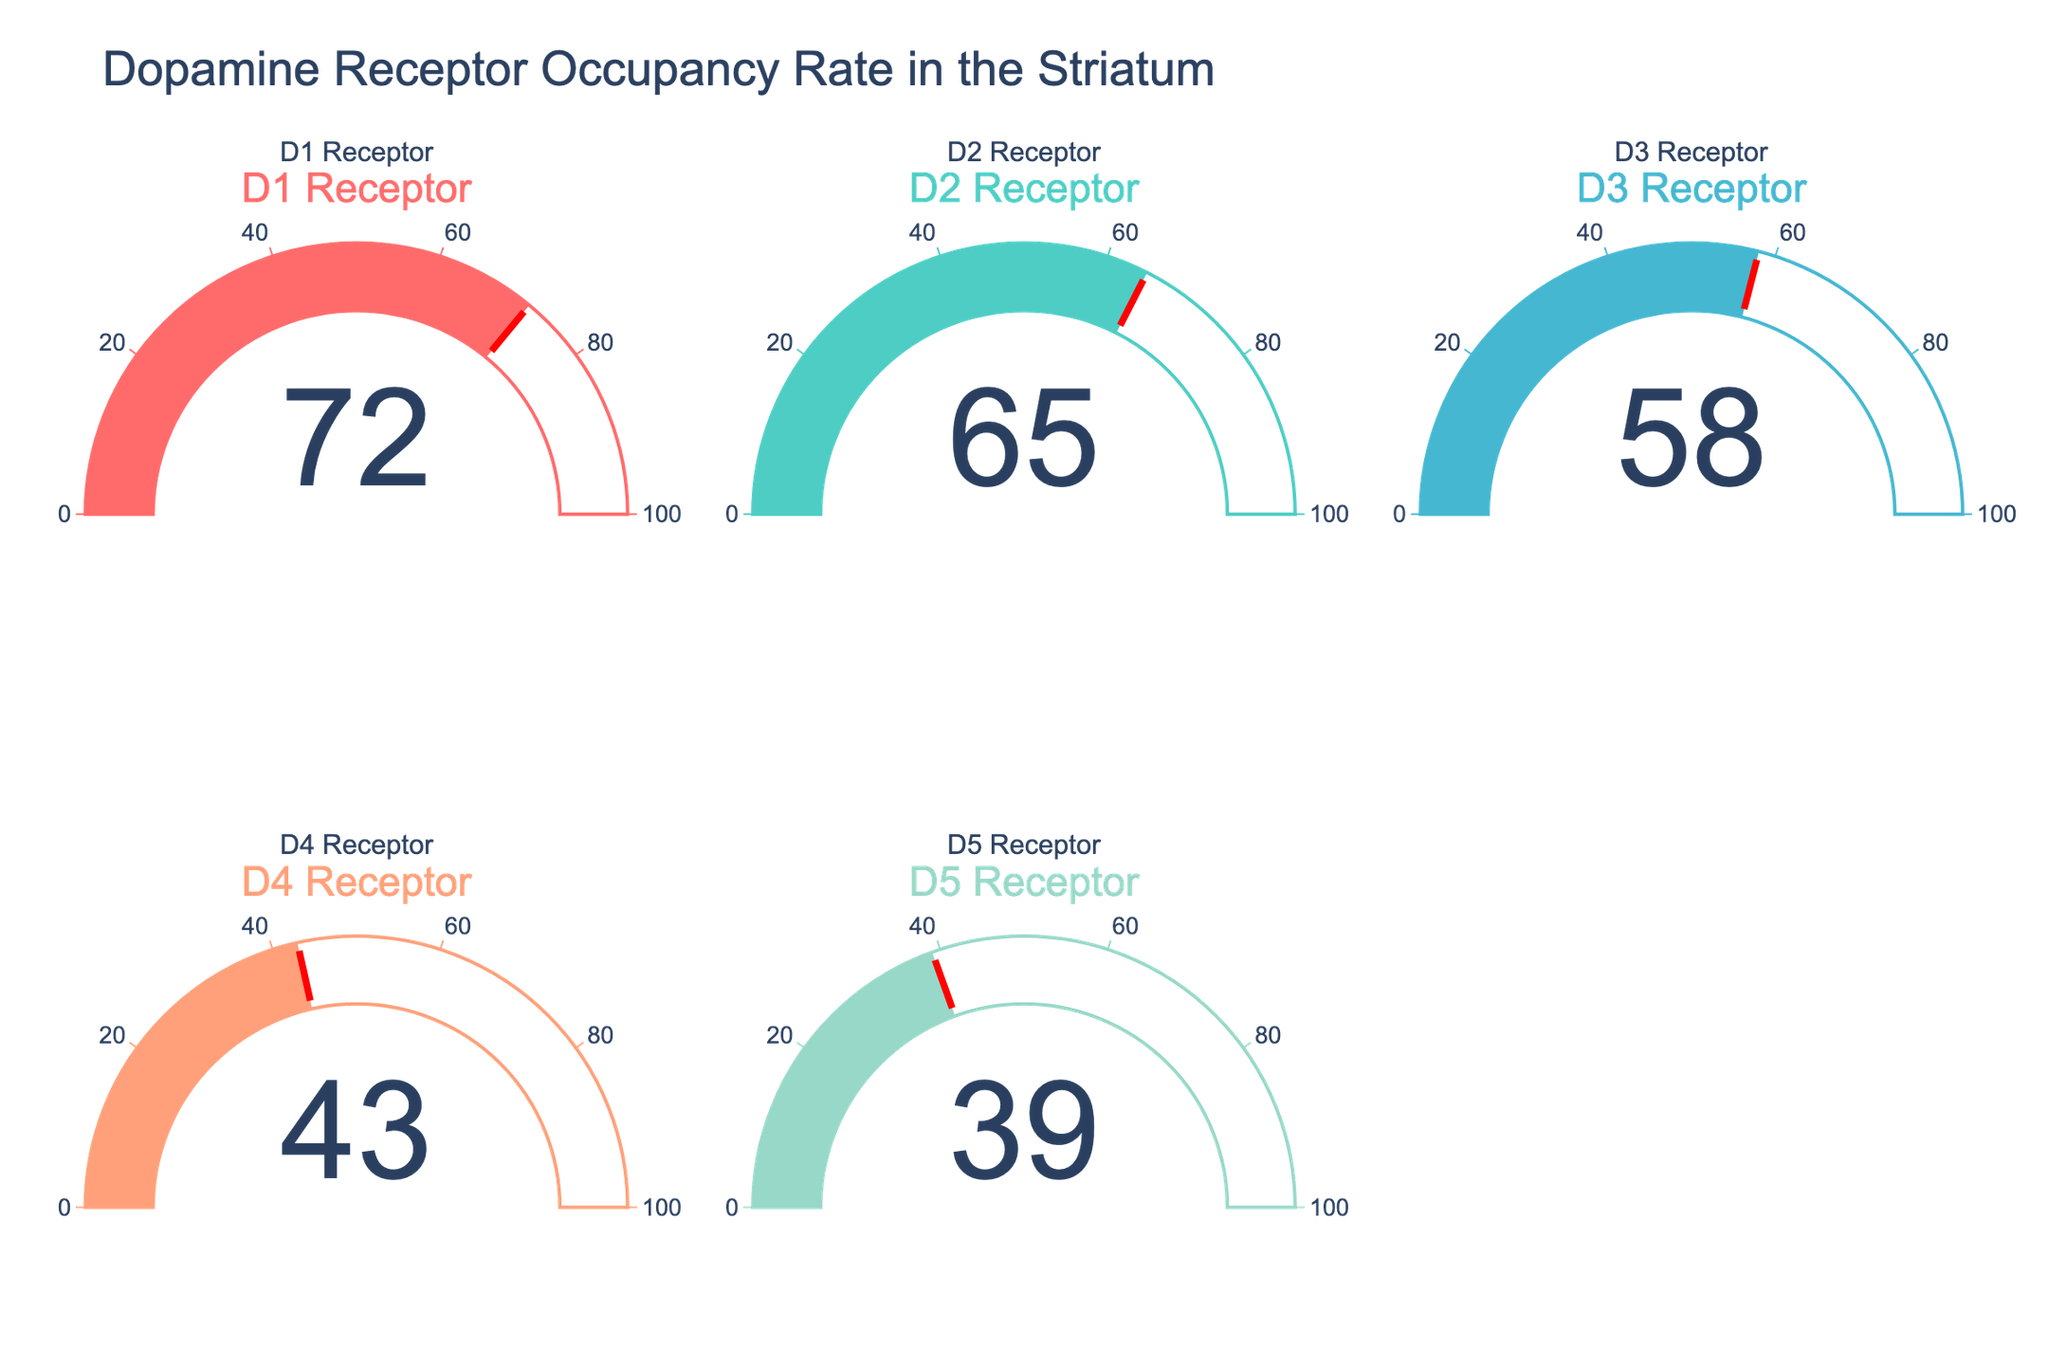Which dopamine receptor has the highest occupancy rate? The gauge chart for the D1 Receptor indicates the highest value of 72, which is higher than any other receptor's occupancy rate.
Answer: D1 Receptor What is the occupancy rate of the D2 Receptor? The gauge for the D2 Receptor shows a value of 65, indicating its occupancy rate.
Answer: 65 How many dopamine receptors have an occupancy rate above 50? By observing the values on each gauge, D1 (72), D2 (65), and D3 (58) all have rates above 50.
Answer: 3 What is the average occupancy rate of D3 and D4 receptors? The D3 Receptor has an occupancy rate of 58 and the D4 Receptor has 43. The average is calculated as (58 + 43) / 2 = 50.5.
Answer: 50.5 Which receptor has the lowest occupancy rate? The gauge chart for the D5 Receptor shows the lowest value of 39, lower than all other receptor rates.
Answer: D5 Receptor What is the difference in occupancy rate between the D1 and D5 receptors? The D1 Receptor has an occupancy rate of 72 while the D5 Receptor has 39. The difference is calculated as 72 - 39 = 33.
Answer: 33 How many receptors have an occupancy rate below 60? By observing the values on each gauge, D4 (43), D5 (39), and D3 (58) all have rates below 60.
Answer: 3 What is the combined occupancy rate of the D1, D2, and D3 receptors? Adding the occupancy rates of these receptors gives: 72 (D1) + 65 (D2) + 58 (D3) = 195.
Answer: 195 Is the D4 receptor's occupancy rate higher than the D5 receptor's occupancy rate? The gauge chart for the D4 Receptor shows a value of 43, which is higher than the D5 Receptor's 39.
Answer: Yes 